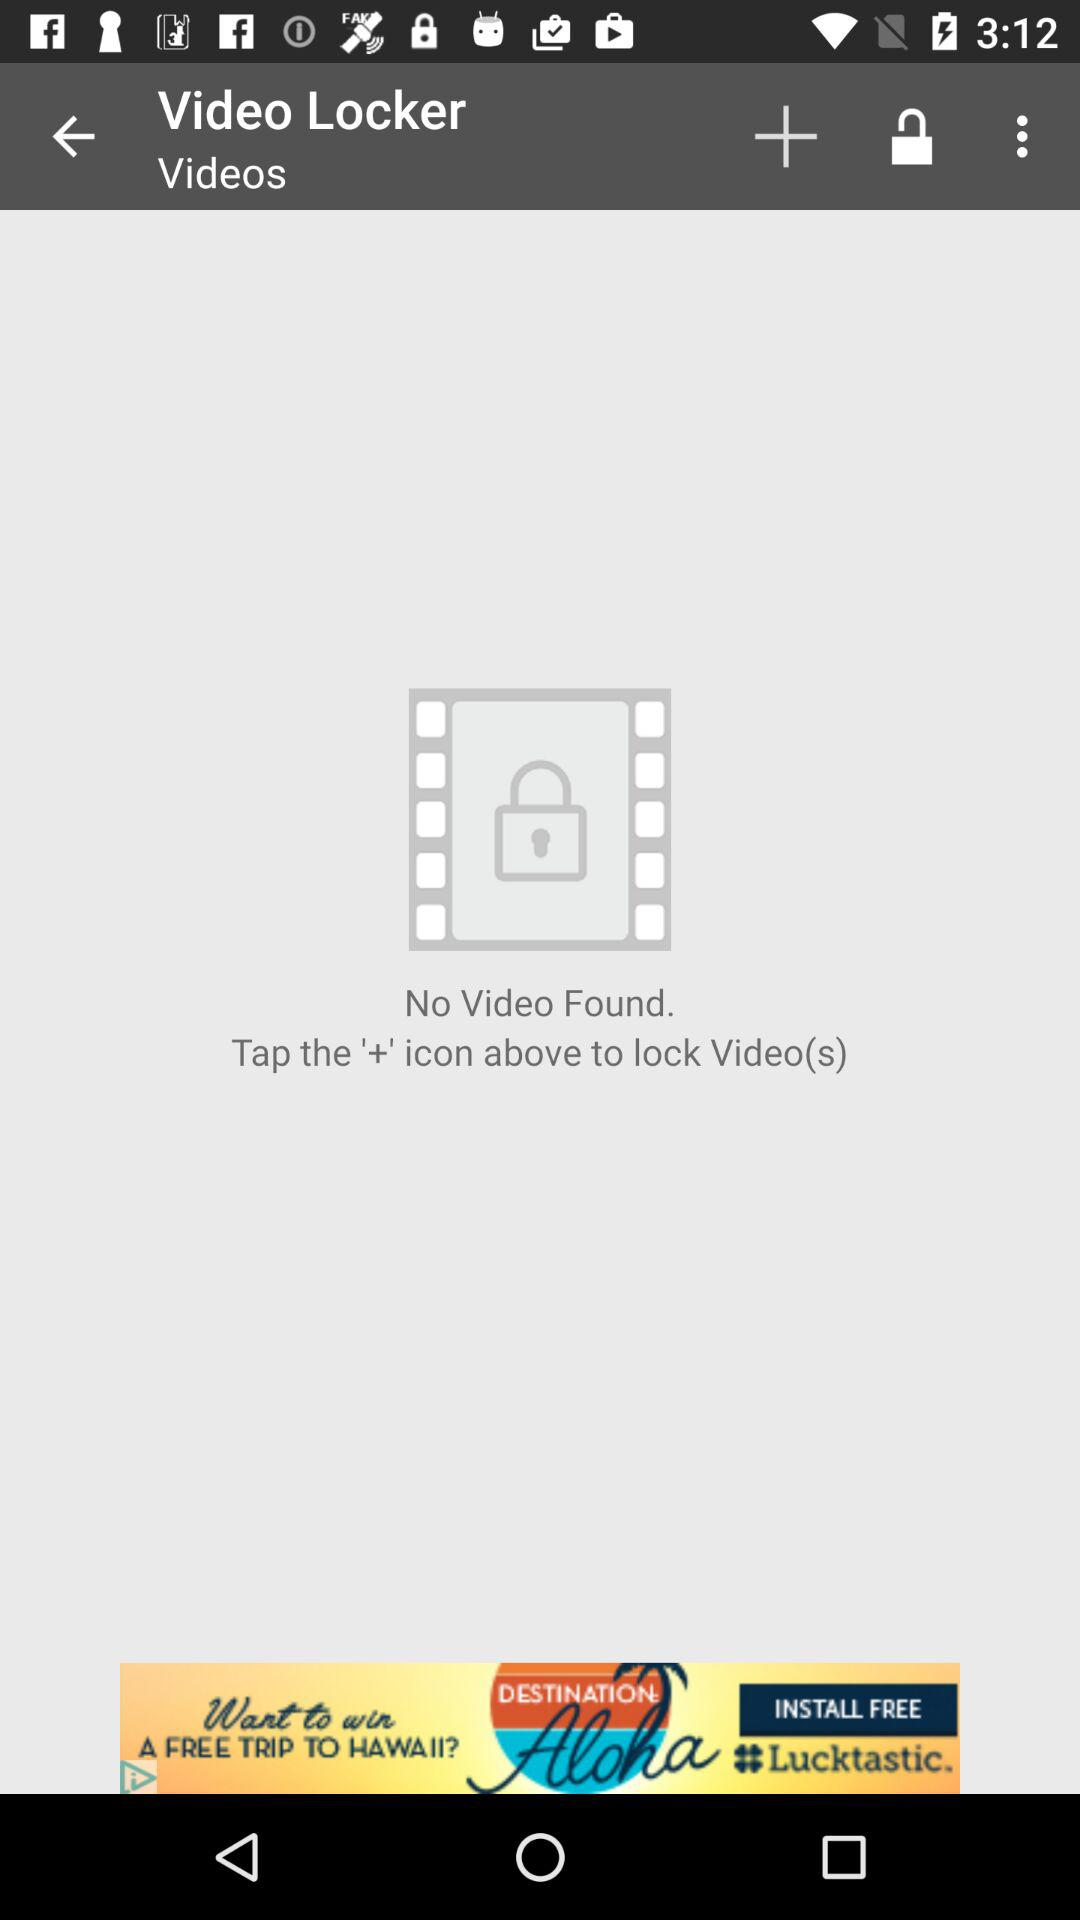What is the application name? The application name is "Video Locker". 